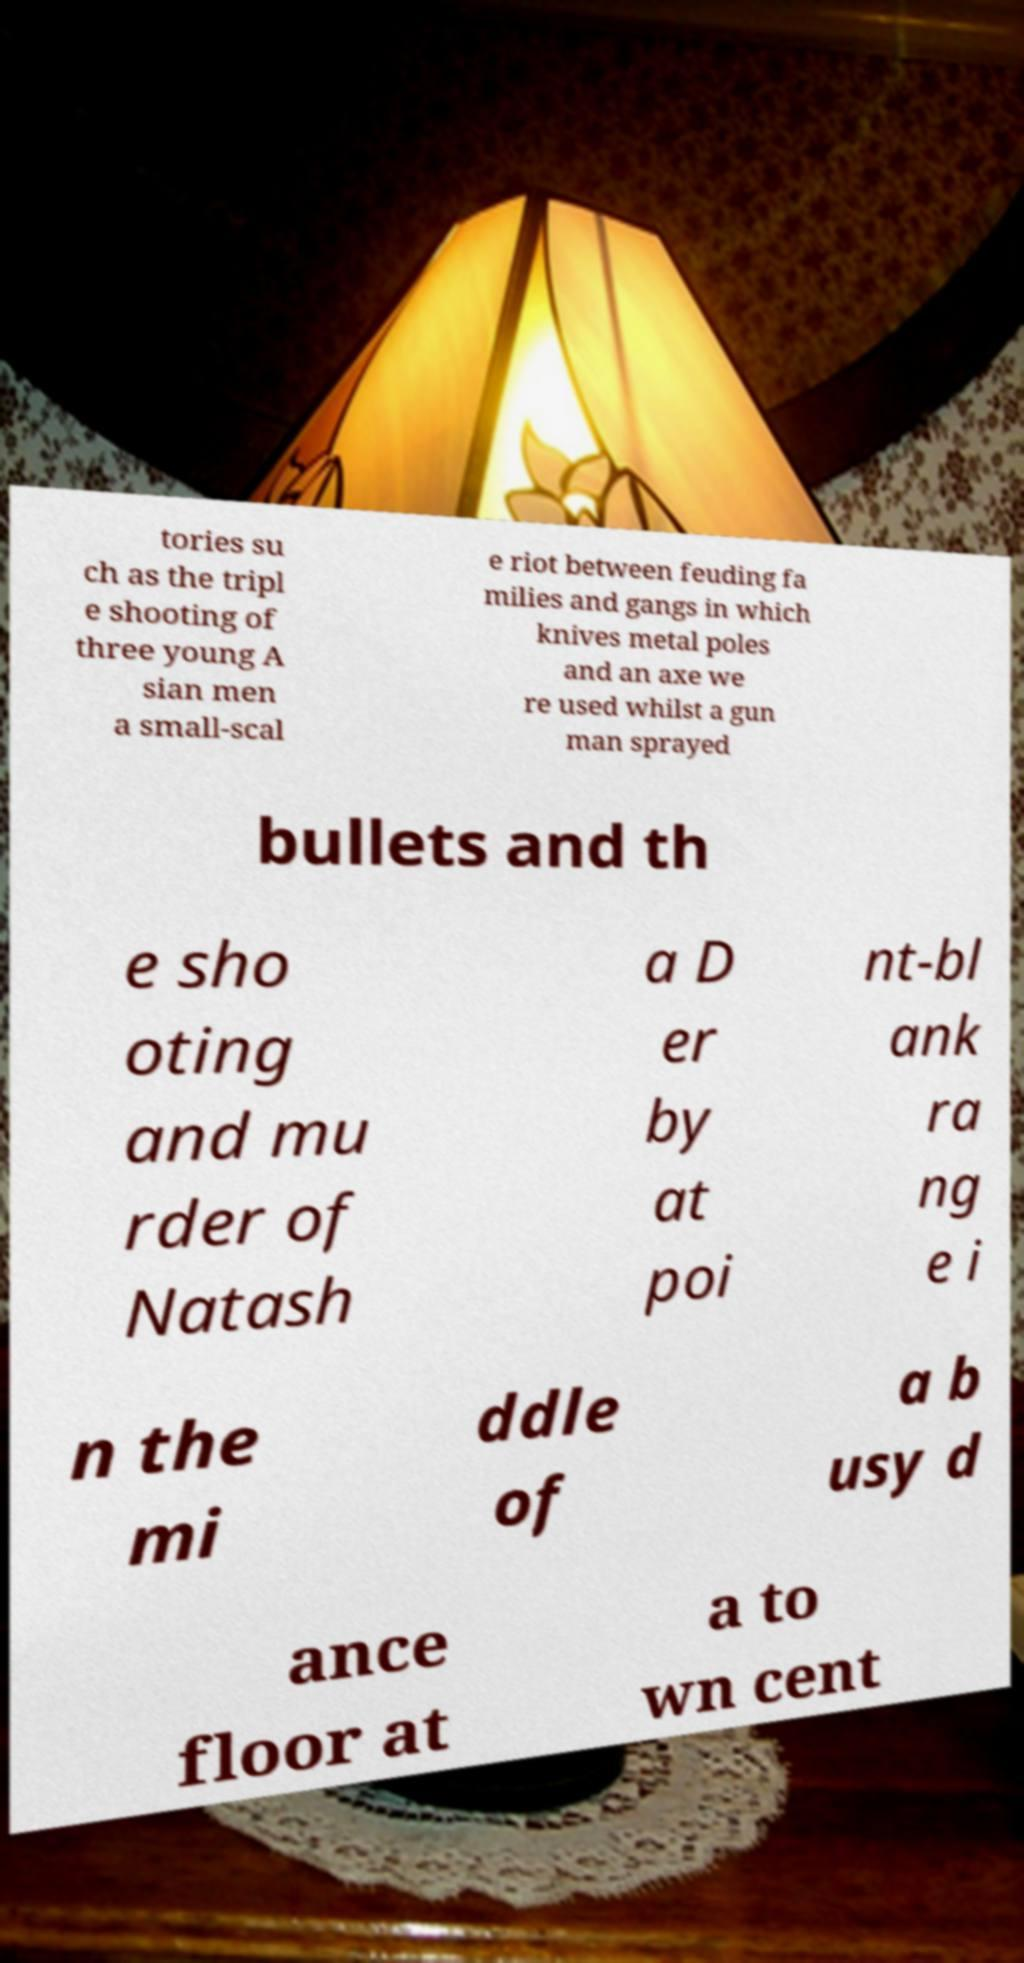Could you extract and type out the text from this image? tories su ch as the tripl e shooting of three young A sian men a small-scal e riot between feuding fa milies and gangs in which knives metal poles and an axe we re used whilst a gun man sprayed bullets and th e sho oting and mu rder of Natash a D er by at poi nt-bl ank ra ng e i n the mi ddle of a b usy d ance floor at a to wn cent 